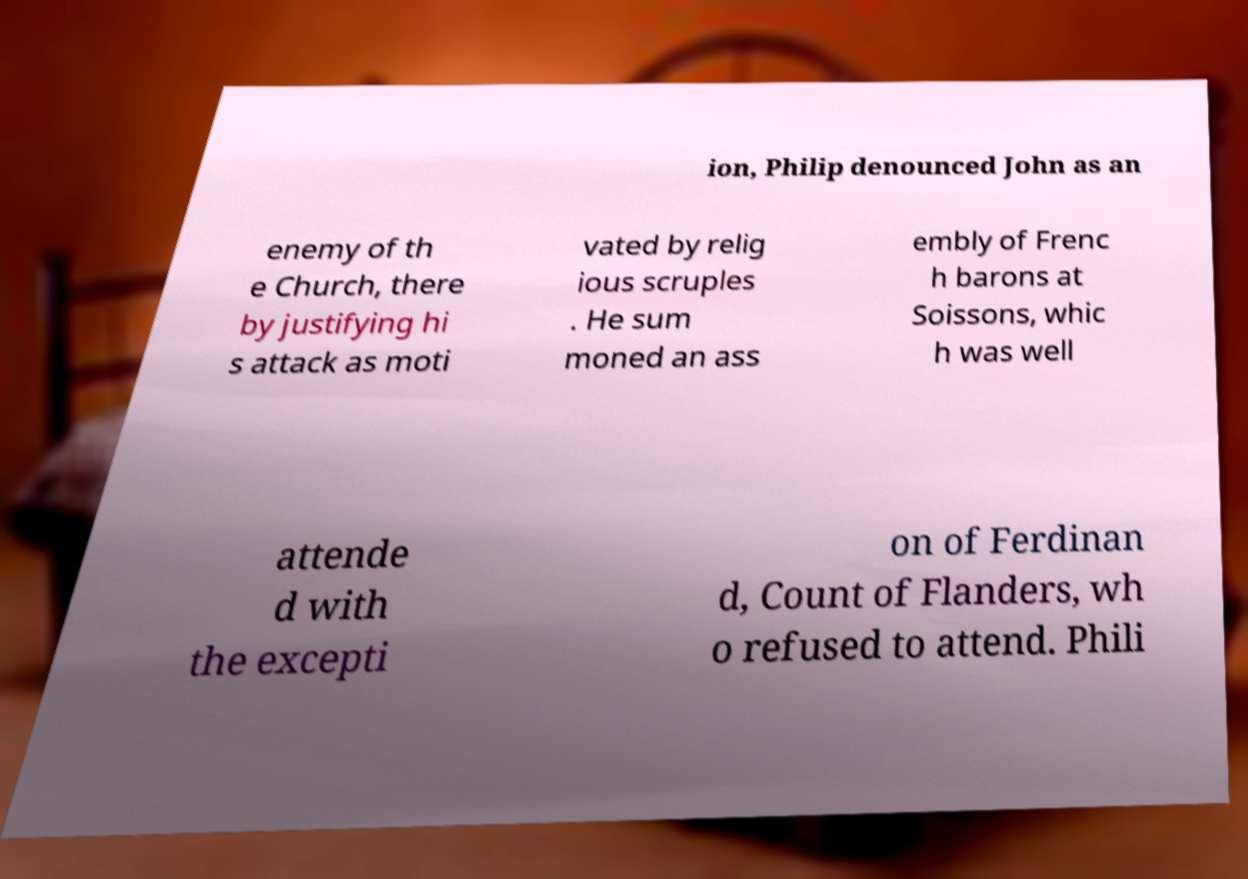Could you extract and type out the text from this image? ion, Philip denounced John as an enemy of th e Church, there by justifying hi s attack as moti vated by relig ious scruples . He sum moned an ass embly of Frenc h barons at Soissons, whic h was well attende d with the excepti on of Ferdinan d, Count of Flanders, wh o refused to attend. Phili 